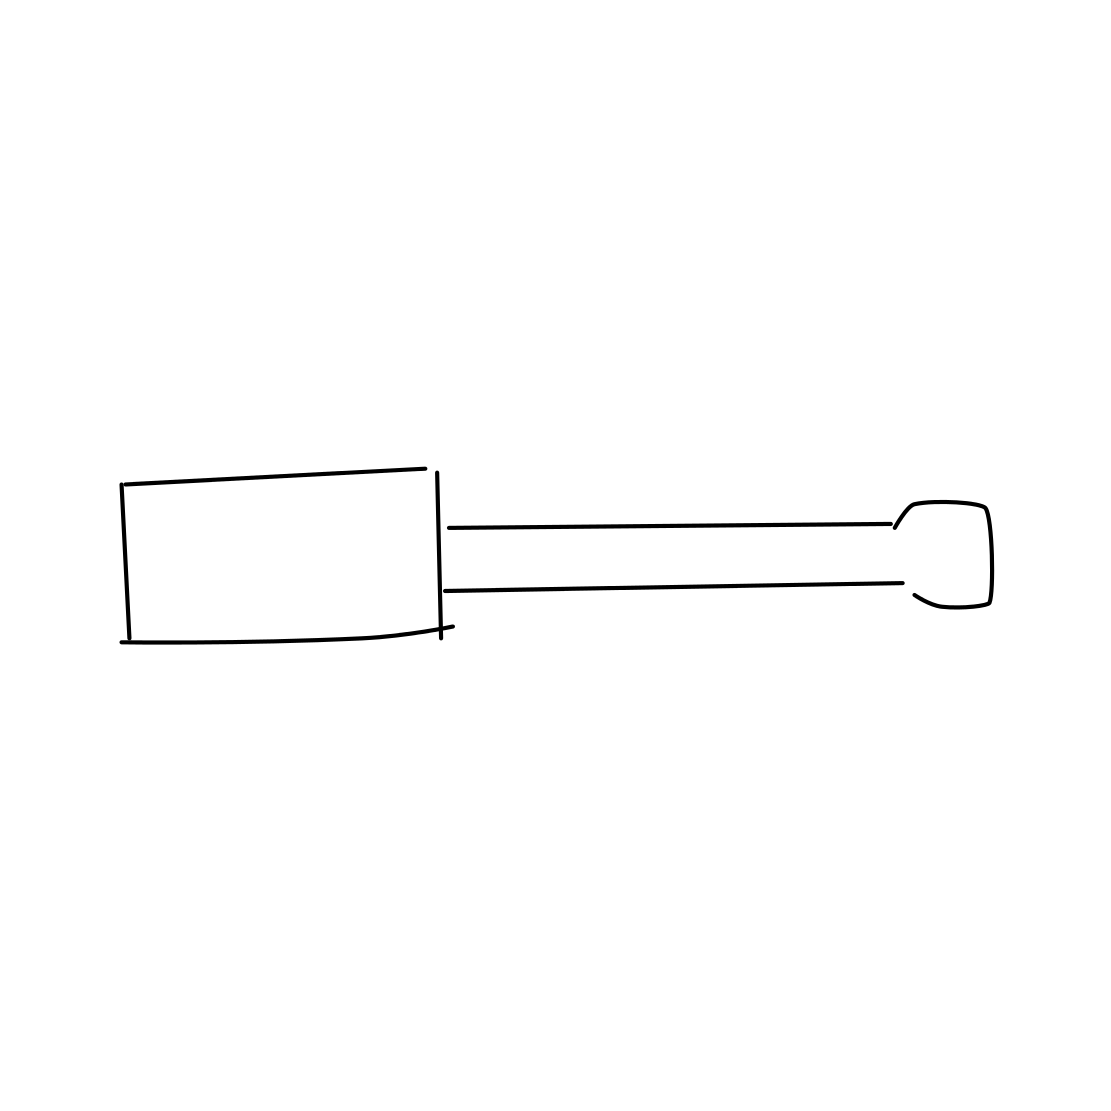Could you guess the potential size of this screwdriver? While it's challenging to infer the exact size without a reference object, the proportions suggest that it's likely a standard-sized screwdriver, commonly used in household tasks or simple mechanical works. 